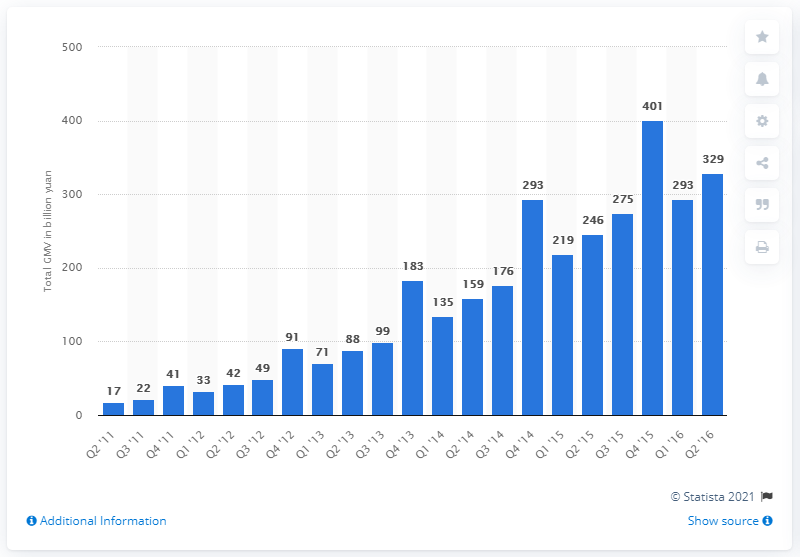Draw attention to some important aspects in this diagram. Tmall's gross merchandise volume (GMV) in the last quarter of 2016 was 329 billion yuan. 